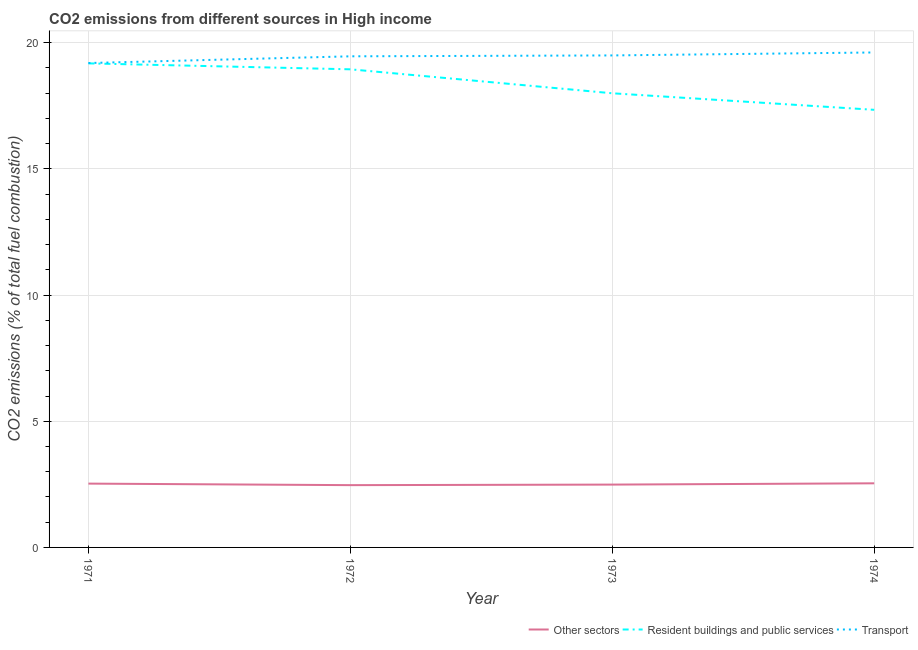Does the line corresponding to percentage of co2 emissions from resident buildings and public services intersect with the line corresponding to percentage of co2 emissions from transport?
Give a very brief answer. No. What is the percentage of co2 emissions from transport in 1972?
Offer a terse response. 19.46. Across all years, what is the maximum percentage of co2 emissions from other sectors?
Provide a short and direct response. 2.54. Across all years, what is the minimum percentage of co2 emissions from resident buildings and public services?
Offer a terse response. 17.34. In which year was the percentage of co2 emissions from other sectors maximum?
Your response must be concise. 1974. What is the total percentage of co2 emissions from resident buildings and public services in the graph?
Offer a terse response. 73.47. What is the difference between the percentage of co2 emissions from transport in 1972 and that in 1973?
Offer a very short reply. -0.04. What is the difference between the percentage of co2 emissions from transport in 1973 and the percentage of co2 emissions from resident buildings and public services in 1972?
Give a very brief answer. 0.55. What is the average percentage of co2 emissions from transport per year?
Ensure brevity in your answer.  19.44. In the year 1972, what is the difference between the percentage of co2 emissions from resident buildings and public services and percentage of co2 emissions from other sectors?
Keep it short and to the point. 16.48. In how many years, is the percentage of co2 emissions from other sectors greater than 5 %?
Offer a very short reply. 0. What is the ratio of the percentage of co2 emissions from transport in 1972 to that in 1973?
Offer a terse response. 1. What is the difference between the highest and the second highest percentage of co2 emissions from other sectors?
Your answer should be very brief. 0.01. What is the difference between the highest and the lowest percentage of co2 emissions from other sectors?
Your answer should be very brief. 0.07. Is the sum of the percentage of co2 emissions from other sectors in 1972 and 1974 greater than the maximum percentage of co2 emissions from transport across all years?
Your answer should be compact. No. How many years are there in the graph?
Your answer should be very brief. 4. What is the difference between two consecutive major ticks on the Y-axis?
Keep it short and to the point. 5. Does the graph contain grids?
Your response must be concise. Yes. Where does the legend appear in the graph?
Give a very brief answer. Bottom right. How many legend labels are there?
Make the answer very short. 3. What is the title of the graph?
Make the answer very short. CO2 emissions from different sources in High income. What is the label or title of the Y-axis?
Provide a short and direct response. CO2 emissions (% of total fuel combustion). What is the CO2 emissions (% of total fuel combustion) of Other sectors in 1971?
Ensure brevity in your answer.  2.53. What is the CO2 emissions (% of total fuel combustion) of Resident buildings and public services in 1971?
Offer a terse response. 19.18. What is the CO2 emissions (% of total fuel combustion) in Transport in 1971?
Make the answer very short. 19.2. What is the CO2 emissions (% of total fuel combustion) of Other sectors in 1972?
Your response must be concise. 2.47. What is the CO2 emissions (% of total fuel combustion) of Resident buildings and public services in 1972?
Your answer should be very brief. 18.95. What is the CO2 emissions (% of total fuel combustion) in Transport in 1972?
Your answer should be compact. 19.46. What is the CO2 emissions (% of total fuel combustion) in Other sectors in 1973?
Provide a succinct answer. 2.49. What is the CO2 emissions (% of total fuel combustion) of Resident buildings and public services in 1973?
Provide a succinct answer. 18. What is the CO2 emissions (% of total fuel combustion) of Transport in 1973?
Ensure brevity in your answer.  19.5. What is the CO2 emissions (% of total fuel combustion) of Other sectors in 1974?
Keep it short and to the point. 2.54. What is the CO2 emissions (% of total fuel combustion) of Resident buildings and public services in 1974?
Your response must be concise. 17.34. What is the CO2 emissions (% of total fuel combustion) in Transport in 1974?
Keep it short and to the point. 19.62. Across all years, what is the maximum CO2 emissions (% of total fuel combustion) of Other sectors?
Offer a terse response. 2.54. Across all years, what is the maximum CO2 emissions (% of total fuel combustion) in Resident buildings and public services?
Offer a very short reply. 19.18. Across all years, what is the maximum CO2 emissions (% of total fuel combustion) in Transport?
Your response must be concise. 19.62. Across all years, what is the minimum CO2 emissions (% of total fuel combustion) in Other sectors?
Provide a short and direct response. 2.47. Across all years, what is the minimum CO2 emissions (% of total fuel combustion) of Resident buildings and public services?
Ensure brevity in your answer.  17.34. Across all years, what is the minimum CO2 emissions (% of total fuel combustion) in Transport?
Provide a short and direct response. 19.2. What is the total CO2 emissions (% of total fuel combustion) of Other sectors in the graph?
Your answer should be very brief. 10.03. What is the total CO2 emissions (% of total fuel combustion) in Resident buildings and public services in the graph?
Your answer should be compact. 73.47. What is the total CO2 emissions (% of total fuel combustion) of Transport in the graph?
Ensure brevity in your answer.  77.77. What is the difference between the CO2 emissions (% of total fuel combustion) in Other sectors in 1971 and that in 1972?
Your answer should be compact. 0.06. What is the difference between the CO2 emissions (% of total fuel combustion) in Resident buildings and public services in 1971 and that in 1972?
Provide a succinct answer. 0.24. What is the difference between the CO2 emissions (% of total fuel combustion) in Transport in 1971 and that in 1972?
Provide a short and direct response. -0.27. What is the difference between the CO2 emissions (% of total fuel combustion) in Other sectors in 1971 and that in 1973?
Offer a very short reply. 0.04. What is the difference between the CO2 emissions (% of total fuel combustion) of Resident buildings and public services in 1971 and that in 1973?
Provide a short and direct response. 1.18. What is the difference between the CO2 emissions (% of total fuel combustion) in Transport in 1971 and that in 1973?
Give a very brief answer. -0.3. What is the difference between the CO2 emissions (% of total fuel combustion) of Other sectors in 1971 and that in 1974?
Your response must be concise. -0.01. What is the difference between the CO2 emissions (% of total fuel combustion) of Resident buildings and public services in 1971 and that in 1974?
Offer a terse response. 1.84. What is the difference between the CO2 emissions (% of total fuel combustion) of Transport in 1971 and that in 1974?
Your answer should be very brief. -0.42. What is the difference between the CO2 emissions (% of total fuel combustion) of Other sectors in 1972 and that in 1973?
Keep it short and to the point. -0.02. What is the difference between the CO2 emissions (% of total fuel combustion) of Resident buildings and public services in 1972 and that in 1973?
Your answer should be compact. 0.95. What is the difference between the CO2 emissions (% of total fuel combustion) in Transport in 1972 and that in 1973?
Your answer should be compact. -0.04. What is the difference between the CO2 emissions (% of total fuel combustion) in Other sectors in 1972 and that in 1974?
Provide a short and direct response. -0.07. What is the difference between the CO2 emissions (% of total fuel combustion) of Resident buildings and public services in 1972 and that in 1974?
Your response must be concise. 1.61. What is the difference between the CO2 emissions (% of total fuel combustion) of Transport in 1972 and that in 1974?
Your answer should be compact. -0.15. What is the difference between the CO2 emissions (% of total fuel combustion) of Other sectors in 1973 and that in 1974?
Make the answer very short. -0.05. What is the difference between the CO2 emissions (% of total fuel combustion) in Resident buildings and public services in 1973 and that in 1974?
Your answer should be very brief. 0.66. What is the difference between the CO2 emissions (% of total fuel combustion) in Transport in 1973 and that in 1974?
Provide a short and direct response. -0.12. What is the difference between the CO2 emissions (% of total fuel combustion) of Other sectors in 1971 and the CO2 emissions (% of total fuel combustion) of Resident buildings and public services in 1972?
Keep it short and to the point. -16.42. What is the difference between the CO2 emissions (% of total fuel combustion) in Other sectors in 1971 and the CO2 emissions (% of total fuel combustion) in Transport in 1972?
Your answer should be very brief. -16.93. What is the difference between the CO2 emissions (% of total fuel combustion) in Resident buildings and public services in 1971 and the CO2 emissions (% of total fuel combustion) in Transport in 1972?
Offer a terse response. -0.28. What is the difference between the CO2 emissions (% of total fuel combustion) in Other sectors in 1971 and the CO2 emissions (% of total fuel combustion) in Resident buildings and public services in 1973?
Your response must be concise. -15.47. What is the difference between the CO2 emissions (% of total fuel combustion) of Other sectors in 1971 and the CO2 emissions (% of total fuel combustion) of Transport in 1973?
Provide a short and direct response. -16.97. What is the difference between the CO2 emissions (% of total fuel combustion) of Resident buildings and public services in 1971 and the CO2 emissions (% of total fuel combustion) of Transport in 1973?
Make the answer very short. -0.32. What is the difference between the CO2 emissions (% of total fuel combustion) in Other sectors in 1971 and the CO2 emissions (% of total fuel combustion) in Resident buildings and public services in 1974?
Offer a terse response. -14.81. What is the difference between the CO2 emissions (% of total fuel combustion) of Other sectors in 1971 and the CO2 emissions (% of total fuel combustion) of Transport in 1974?
Offer a very short reply. -17.09. What is the difference between the CO2 emissions (% of total fuel combustion) in Resident buildings and public services in 1971 and the CO2 emissions (% of total fuel combustion) in Transport in 1974?
Your response must be concise. -0.43. What is the difference between the CO2 emissions (% of total fuel combustion) of Other sectors in 1972 and the CO2 emissions (% of total fuel combustion) of Resident buildings and public services in 1973?
Offer a very short reply. -15.53. What is the difference between the CO2 emissions (% of total fuel combustion) of Other sectors in 1972 and the CO2 emissions (% of total fuel combustion) of Transport in 1973?
Offer a very short reply. -17.03. What is the difference between the CO2 emissions (% of total fuel combustion) of Resident buildings and public services in 1972 and the CO2 emissions (% of total fuel combustion) of Transport in 1973?
Give a very brief answer. -0.55. What is the difference between the CO2 emissions (% of total fuel combustion) of Other sectors in 1972 and the CO2 emissions (% of total fuel combustion) of Resident buildings and public services in 1974?
Your response must be concise. -14.87. What is the difference between the CO2 emissions (% of total fuel combustion) of Other sectors in 1972 and the CO2 emissions (% of total fuel combustion) of Transport in 1974?
Offer a terse response. -17.15. What is the difference between the CO2 emissions (% of total fuel combustion) in Resident buildings and public services in 1972 and the CO2 emissions (% of total fuel combustion) in Transport in 1974?
Your answer should be compact. -0.67. What is the difference between the CO2 emissions (% of total fuel combustion) in Other sectors in 1973 and the CO2 emissions (% of total fuel combustion) in Resident buildings and public services in 1974?
Keep it short and to the point. -14.85. What is the difference between the CO2 emissions (% of total fuel combustion) in Other sectors in 1973 and the CO2 emissions (% of total fuel combustion) in Transport in 1974?
Offer a very short reply. -17.13. What is the difference between the CO2 emissions (% of total fuel combustion) in Resident buildings and public services in 1973 and the CO2 emissions (% of total fuel combustion) in Transport in 1974?
Provide a succinct answer. -1.62. What is the average CO2 emissions (% of total fuel combustion) in Other sectors per year?
Ensure brevity in your answer.  2.51. What is the average CO2 emissions (% of total fuel combustion) of Resident buildings and public services per year?
Your answer should be very brief. 18.37. What is the average CO2 emissions (% of total fuel combustion) of Transport per year?
Your answer should be compact. 19.44. In the year 1971, what is the difference between the CO2 emissions (% of total fuel combustion) in Other sectors and CO2 emissions (% of total fuel combustion) in Resident buildings and public services?
Make the answer very short. -16.65. In the year 1971, what is the difference between the CO2 emissions (% of total fuel combustion) of Other sectors and CO2 emissions (% of total fuel combustion) of Transport?
Your answer should be compact. -16.67. In the year 1971, what is the difference between the CO2 emissions (% of total fuel combustion) of Resident buildings and public services and CO2 emissions (% of total fuel combustion) of Transport?
Your response must be concise. -0.01. In the year 1972, what is the difference between the CO2 emissions (% of total fuel combustion) in Other sectors and CO2 emissions (% of total fuel combustion) in Resident buildings and public services?
Provide a succinct answer. -16.48. In the year 1972, what is the difference between the CO2 emissions (% of total fuel combustion) of Other sectors and CO2 emissions (% of total fuel combustion) of Transport?
Make the answer very short. -16.99. In the year 1972, what is the difference between the CO2 emissions (% of total fuel combustion) of Resident buildings and public services and CO2 emissions (% of total fuel combustion) of Transport?
Make the answer very short. -0.52. In the year 1973, what is the difference between the CO2 emissions (% of total fuel combustion) in Other sectors and CO2 emissions (% of total fuel combustion) in Resident buildings and public services?
Provide a succinct answer. -15.51. In the year 1973, what is the difference between the CO2 emissions (% of total fuel combustion) in Other sectors and CO2 emissions (% of total fuel combustion) in Transport?
Provide a short and direct response. -17.01. In the year 1973, what is the difference between the CO2 emissions (% of total fuel combustion) of Resident buildings and public services and CO2 emissions (% of total fuel combustion) of Transport?
Your answer should be very brief. -1.5. In the year 1974, what is the difference between the CO2 emissions (% of total fuel combustion) in Other sectors and CO2 emissions (% of total fuel combustion) in Resident buildings and public services?
Your answer should be very brief. -14.8. In the year 1974, what is the difference between the CO2 emissions (% of total fuel combustion) in Other sectors and CO2 emissions (% of total fuel combustion) in Transport?
Your answer should be very brief. -17.07. In the year 1974, what is the difference between the CO2 emissions (% of total fuel combustion) of Resident buildings and public services and CO2 emissions (% of total fuel combustion) of Transport?
Provide a succinct answer. -2.27. What is the ratio of the CO2 emissions (% of total fuel combustion) of Other sectors in 1971 to that in 1972?
Your response must be concise. 1.02. What is the ratio of the CO2 emissions (% of total fuel combustion) in Resident buildings and public services in 1971 to that in 1972?
Ensure brevity in your answer.  1.01. What is the ratio of the CO2 emissions (% of total fuel combustion) in Transport in 1971 to that in 1972?
Provide a short and direct response. 0.99. What is the ratio of the CO2 emissions (% of total fuel combustion) of Other sectors in 1971 to that in 1973?
Ensure brevity in your answer.  1.02. What is the ratio of the CO2 emissions (% of total fuel combustion) of Resident buildings and public services in 1971 to that in 1973?
Give a very brief answer. 1.07. What is the ratio of the CO2 emissions (% of total fuel combustion) of Transport in 1971 to that in 1973?
Give a very brief answer. 0.98. What is the ratio of the CO2 emissions (% of total fuel combustion) of Other sectors in 1971 to that in 1974?
Your answer should be compact. 1. What is the ratio of the CO2 emissions (% of total fuel combustion) of Resident buildings and public services in 1971 to that in 1974?
Offer a terse response. 1.11. What is the ratio of the CO2 emissions (% of total fuel combustion) in Transport in 1971 to that in 1974?
Provide a short and direct response. 0.98. What is the ratio of the CO2 emissions (% of total fuel combustion) of Other sectors in 1972 to that in 1973?
Provide a short and direct response. 0.99. What is the ratio of the CO2 emissions (% of total fuel combustion) of Resident buildings and public services in 1972 to that in 1973?
Offer a very short reply. 1.05. What is the ratio of the CO2 emissions (% of total fuel combustion) of Other sectors in 1972 to that in 1974?
Make the answer very short. 0.97. What is the ratio of the CO2 emissions (% of total fuel combustion) of Resident buildings and public services in 1972 to that in 1974?
Make the answer very short. 1.09. What is the ratio of the CO2 emissions (% of total fuel combustion) in Other sectors in 1973 to that in 1974?
Provide a short and direct response. 0.98. What is the ratio of the CO2 emissions (% of total fuel combustion) in Resident buildings and public services in 1973 to that in 1974?
Offer a terse response. 1.04. What is the ratio of the CO2 emissions (% of total fuel combustion) of Transport in 1973 to that in 1974?
Ensure brevity in your answer.  0.99. What is the difference between the highest and the second highest CO2 emissions (% of total fuel combustion) of Other sectors?
Your answer should be compact. 0.01. What is the difference between the highest and the second highest CO2 emissions (% of total fuel combustion) of Resident buildings and public services?
Your answer should be very brief. 0.24. What is the difference between the highest and the second highest CO2 emissions (% of total fuel combustion) in Transport?
Give a very brief answer. 0.12. What is the difference between the highest and the lowest CO2 emissions (% of total fuel combustion) of Other sectors?
Offer a very short reply. 0.07. What is the difference between the highest and the lowest CO2 emissions (% of total fuel combustion) in Resident buildings and public services?
Provide a short and direct response. 1.84. What is the difference between the highest and the lowest CO2 emissions (% of total fuel combustion) in Transport?
Your answer should be compact. 0.42. 